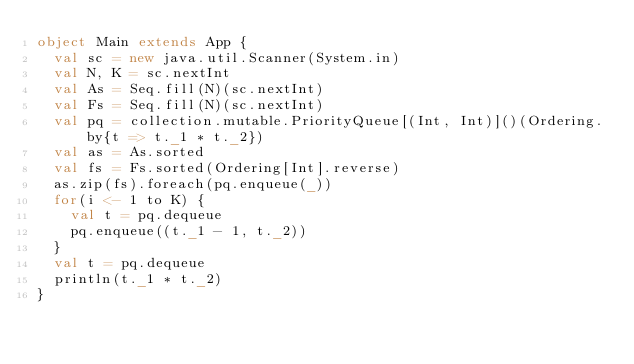Convert code to text. <code><loc_0><loc_0><loc_500><loc_500><_Scala_>object Main extends App {
  val sc = new java.util.Scanner(System.in)
  val N, K = sc.nextInt
  val As = Seq.fill(N)(sc.nextInt)
  val Fs = Seq.fill(N)(sc.nextInt)
  val pq = collection.mutable.PriorityQueue[(Int, Int)]()(Ordering.by{t => t._1 * t._2})
  val as = As.sorted
  val fs = Fs.sorted(Ordering[Int].reverse)
  as.zip(fs).foreach(pq.enqueue(_))
  for(i <- 1 to K) {
    val t = pq.dequeue
    pq.enqueue((t._1 - 1, t._2))
  }
  val t = pq.dequeue
  println(t._1 * t._2)
}</code> 